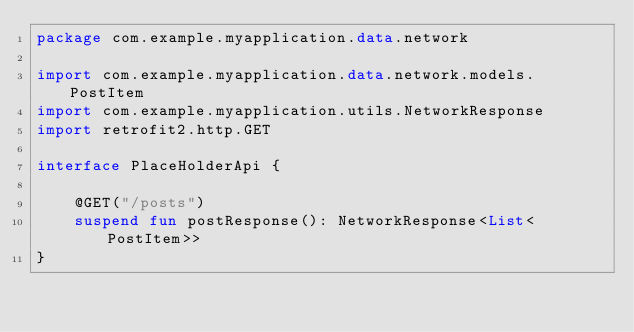<code> <loc_0><loc_0><loc_500><loc_500><_Kotlin_>package com.example.myapplication.data.network

import com.example.myapplication.data.network.models.PostItem
import com.example.myapplication.utils.NetworkResponse
import retrofit2.http.GET

interface PlaceHolderApi {

    @GET("/posts")
    suspend fun postResponse(): NetworkResponse<List<PostItem>>
}</code> 